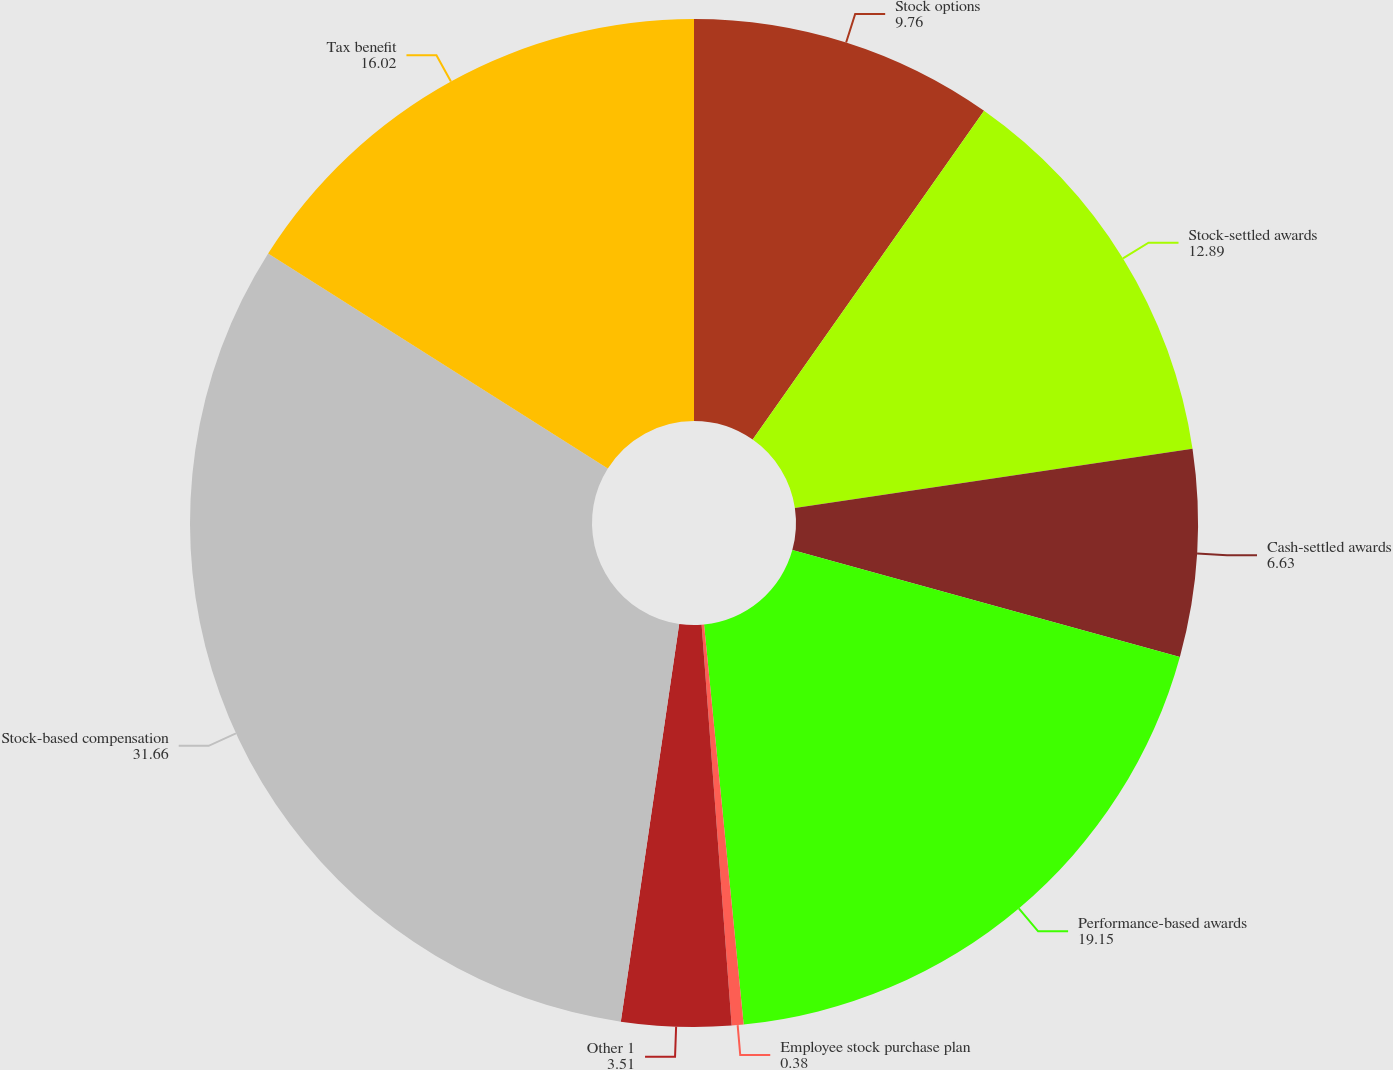Convert chart to OTSL. <chart><loc_0><loc_0><loc_500><loc_500><pie_chart><fcel>Stock options<fcel>Stock-settled awards<fcel>Cash-settled awards<fcel>Performance-based awards<fcel>Employee stock purchase plan<fcel>Other 1<fcel>Stock-based compensation<fcel>Tax benefit<nl><fcel>9.76%<fcel>12.89%<fcel>6.63%<fcel>19.15%<fcel>0.38%<fcel>3.51%<fcel>31.66%<fcel>16.02%<nl></chart> 